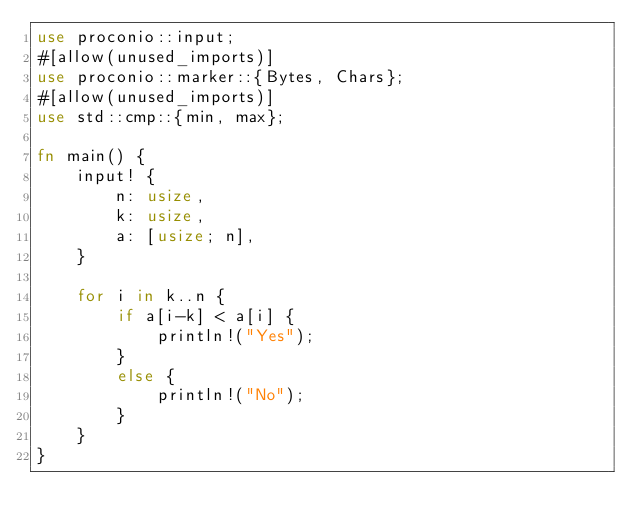<code> <loc_0><loc_0><loc_500><loc_500><_Rust_>use proconio::input;
#[allow(unused_imports)]
use proconio::marker::{Bytes, Chars};
#[allow(unused_imports)]
use std::cmp::{min, max};

fn main() {
	input! {
		n: usize,
		k: usize,
		a: [usize; n],
	}

	for i in k..n {
		if a[i-k] < a[i] {
			println!("Yes");
		}
		else {
			println!("No");
		}
	}
}

</code> 